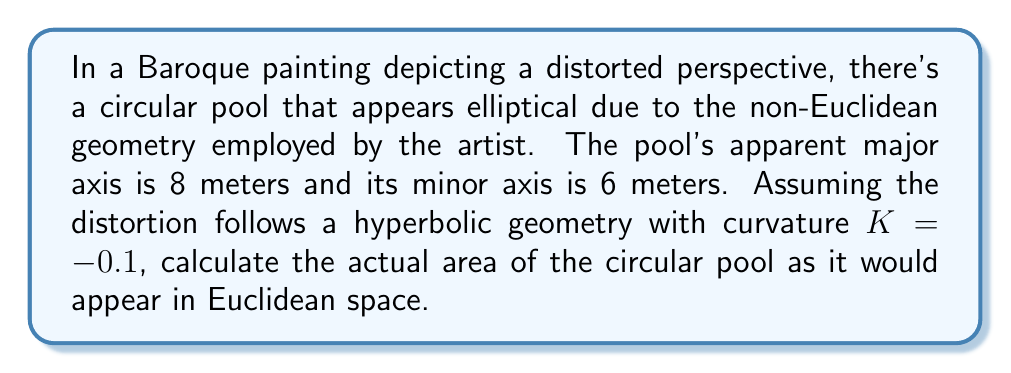Provide a solution to this math problem. To solve this problem, we'll follow these steps:

1) In hyperbolic geometry, the area of an ellipse is given by:

   $$A_h = \frac{4\pi}{\sqrt{-K}} \sinh(\frac{a\sqrt{-K}}{2}) \sinh(\frac{b\sqrt{-K}}{2})$$

   where $a$ and $b$ are the semi-major and semi-minor axes, and $K$ is the curvature.

2) Calculate the semi-major and semi-minor axes:
   $a = 8/2 = 4$ meters
   $b = 6/2 = 3$ meters

3) Substitute the values into the formula:

   $$A_h = \frac{4\pi}{\sqrt{-(-0.1)}} \sinh(\frac{4\sqrt{-(-0.1)}}{2}) \sinh(\frac{3\sqrt{-(-0.1)}}{2})$$

4) Simplify:

   $$A_h = \frac{4\pi}{\sqrt{0.1}} \sinh(0.6325) \sinh(0.4743)$$

5) Calculate:

   $$A_h \approx 39.8396 \text{ square meters}$$

6) This is the apparent area in hyperbolic space. To find the actual area in Euclidean space, we need to use the fact that in hyperbolic geometry, areas appear larger than they actually are.

7) The relationship between hyperbolic and Euclidean areas for small regions is approximately:

   $$A_e \approx A_h (1 + \frac{KA_h}{12\pi})$$

8) Substitute the values:

   $$A_e \approx 39.8396 (1 + \frac{-0.1 \cdot 39.8396}{12\pi})$$

9) Calculate:

   $$A_e \approx 38.7846 \text{ square meters}$$

This is the actual area of the circular pool in Euclidean space.
Answer: $38.78 \text{ m}^2$ 